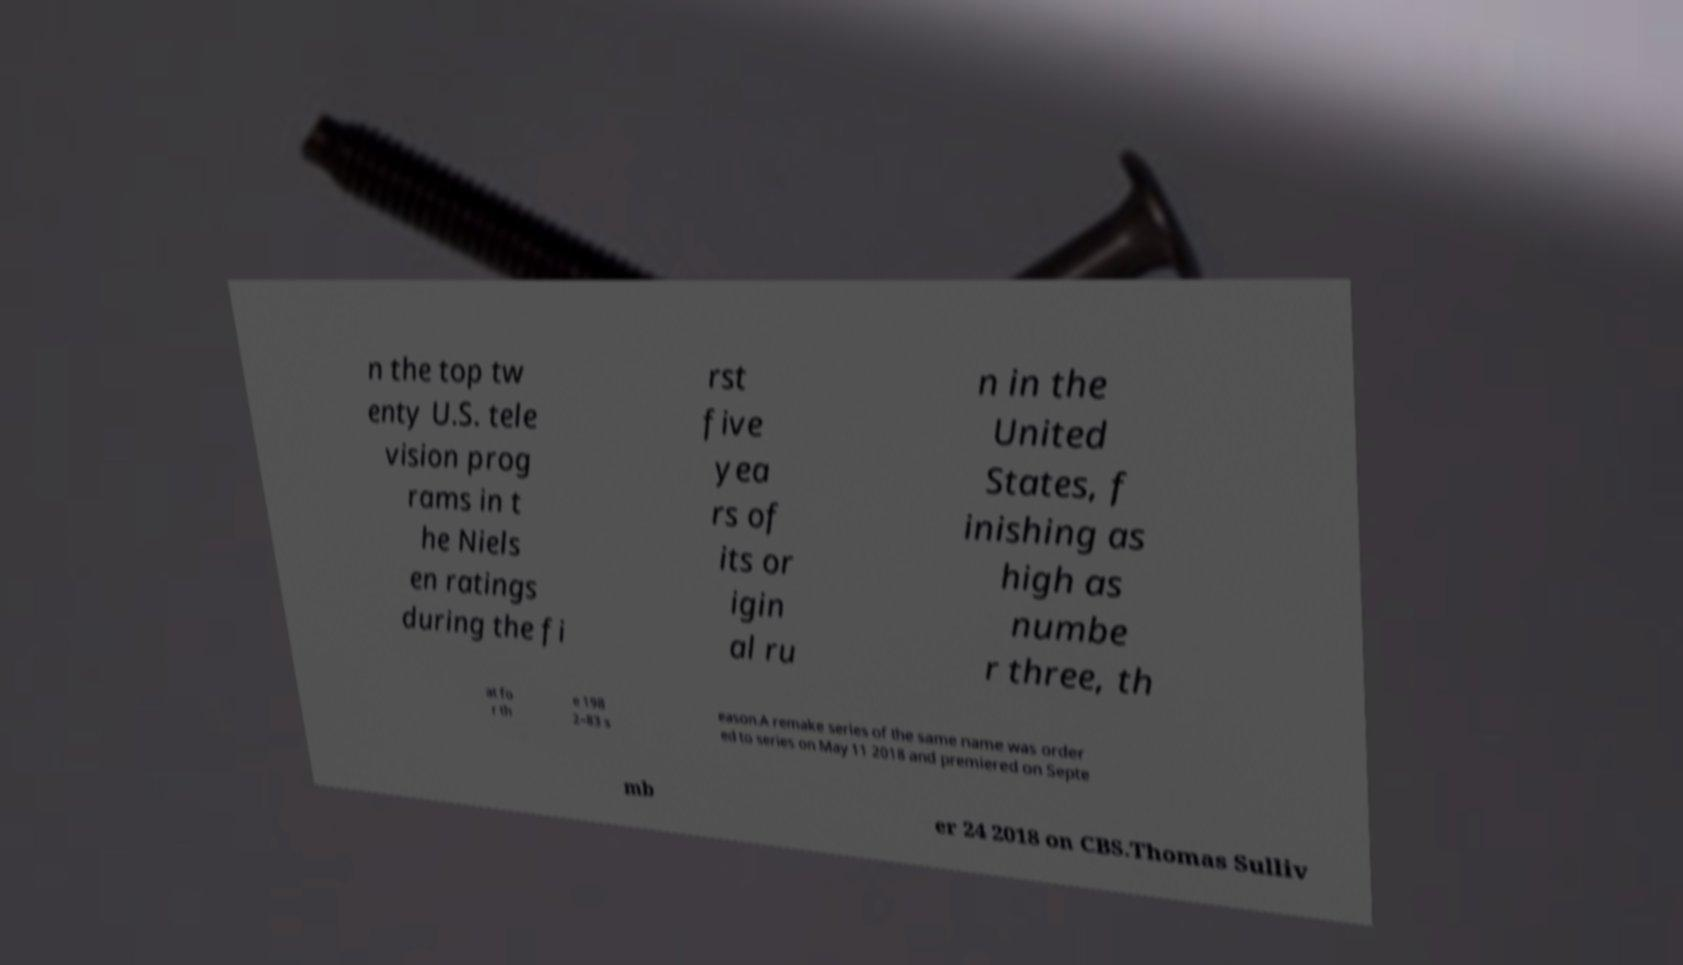I need the written content from this picture converted into text. Can you do that? n the top tw enty U.S. tele vision prog rams in t he Niels en ratings during the fi rst five yea rs of its or igin al ru n in the United States, f inishing as high as numbe r three, th at fo r th e 198 2–83 s eason.A remake series of the same name was order ed to series on May 11 2018 and premiered on Septe mb er 24 2018 on CBS.Thomas Sulliv 